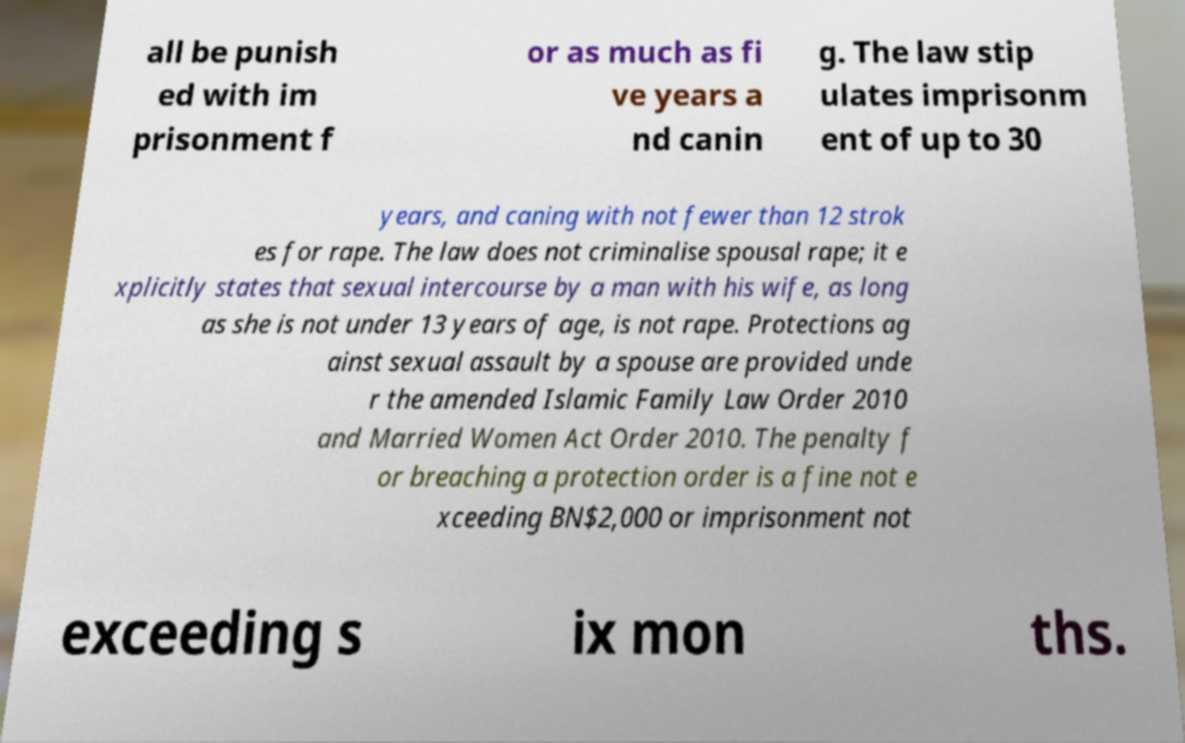Can you accurately transcribe the text from the provided image for me? all be punish ed with im prisonment f or as much as fi ve years a nd canin g. The law stip ulates imprisonm ent of up to 30 years, and caning with not fewer than 12 strok es for rape. The law does not criminalise spousal rape; it e xplicitly states that sexual intercourse by a man with his wife, as long as she is not under 13 years of age, is not rape. Protections ag ainst sexual assault by a spouse are provided unde r the amended Islamic Family Law Order 2010 and Married Women Act Order 2010. The penalty f or breaching a protection order is a fine not e xceeding BN$2,000 or imprisonment not exceeding s ix mon ths. 